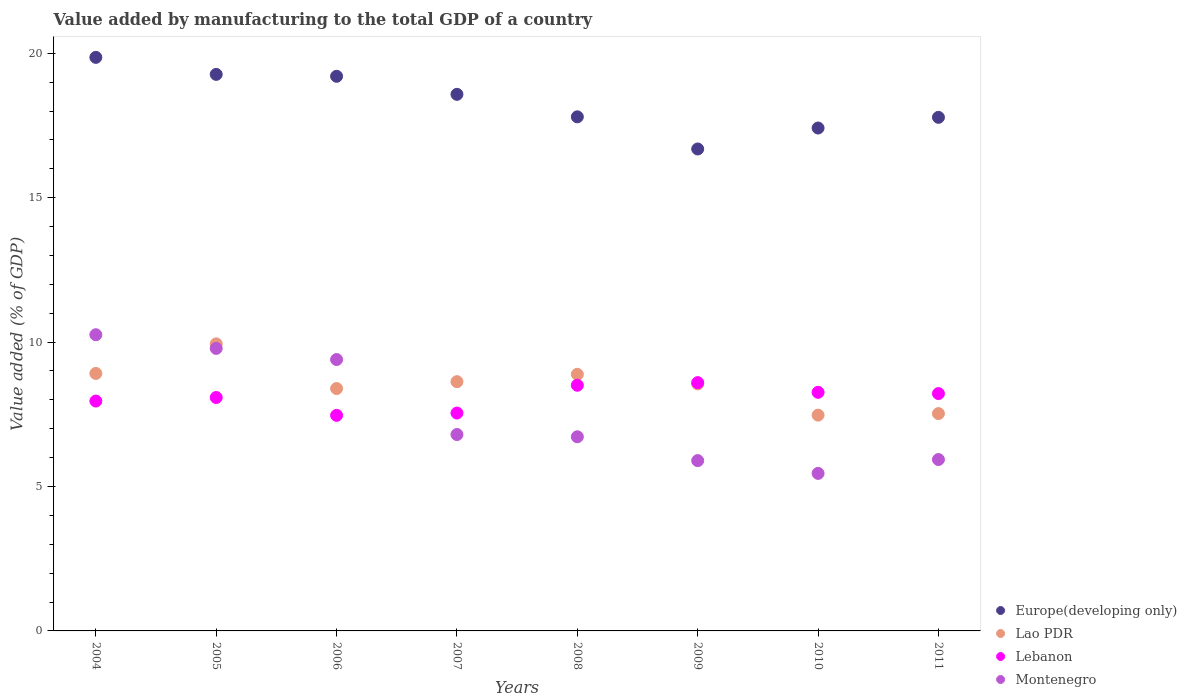What is the value added by manufacturing to the total GDP in Lebanon in 2005?
Give a very brief answer. 8.08. Across all years, what is the maximum value added by manufacturing to the total GDP in Europe(developing only)?
Provide a succinct answer. 19.86. Across all years, what is the minimum value added by manufacturing to the total GDP in Lebanon?
Offer a very short reply. 7.46. In which year was the value added by manufacturing to the total GDP in Montenegro maximum?
Offer a very short reply. 2004. What is the total value added by manufacturing to the total GDP in Lao PDR in the graph?
Your response must be concise. 68.31. What is the difference between the value added by manufacturing to the total GDP in Montenegro in 2005 and that in 2009?
Give a very brief answer. 3.89. What is the difference between the value added by manufacturing to the total GDP in Europe(developing only) in 2005 and the value added by manufacturing to the total GDP in Lao PDR in 2009?
Give a very brief answer. 10.72. What is the average value added by manufacturing to the total GDP in Lebanon per year?
Provide a short and direct response. 8.08. In the year 2008, what is the difference between the value added by manufacturing to the total GDP in Lebanon and value added by manufacturing to the total GDP in Europe(developing only)?
Offer a terse response. -9.29. What is the ratio of the value added by manufacturing to the total GDP in Europe(developing only) in 2007 to that in 2008?
Make the answer very short. 1.04. Is the value added by manufacturing to the total GDP in Europe(developing only) in 2006 less than that in 2010?
Offer a very short reply. No. What is the difference between the highest and the second highest value added by manufacturing to the total GDP in Europe(developing only)?
Offer a terse response. 0.59. What is the difference between the highest and the lowest value added by manufacturing to the total GDP in Europe(developing only)?
Make the answer very short. 3.17. Is it the case that in every year, the sum of the value added by manufacturing to the total GDP in Montenegro and value added by manufacturing to the total GDP in Europe(developing only)  is greater than the sum of value added by manufacturing to the total GDP in Lebanon and value added by manufacturing to the total GDP in Lao PDR?
Your response must be concise. No. Is it the case that in every year, the sum of the value added by manufacturing to the total GDP in Montenegro and value added by manufacturing to the total GDP in Lebanon  is greater than the value added by manufacturing to the total GDP in Europe(developing only)?
Your answer should be compact. No. Is the value added by manufacturing to the total GDP in Lebanon strictly greater than the value added by manufacturing to the total GDP in Europe(developing only) over the years?
Offer a very short reply. No. Are the values on the major ticks of Y-axis written in scientific E-notation?
Keep it short and to the point. No. Does the graph contain any zero values?
Give a very brief answer. No. Where does the legend appear in the graph?
Offer a very short reply. Bottom right. What is the title of the graph?
Make the answer very short. Value added by manufacturing to the total GDP of a country. What is the label or title of the X-axis?
Your answer should be compact. Years. What is the label or title of the Y-axis?
Your answer should be very brief. Value added (% of GDP). What is the Value added (% of GDP) in Europe(developing only) in 2004?
Your response must be concise. 19.86. What is the Value added (% of GDP) of Lao PDR in 2004?
Offer a very short reply. 8.91. What is the Value added (% of GDP) of Lebanon in 2004?
Offer a very short reply. 7.96. What is the Value added (% of GDP) of Montenegro in 2004?
Provide a succinct answer. 10.25. What is the Value added (% of GDP) in Europe(developing only) in 2005?
Your answer should be very brief. 19.27. What is the Value added (% of GDP) of Lao PDR in 2005?
Give a very brief answer. 9.94. What is the Value added (% of GDP) in Lebanon in 2005?
Provide a succinct answer. 8.08. What is the Value added (% of GDP) of Montenegro in 2005?
Give a very brief answer. 9.78. What is the Value added (% of GDP) in Europe(developing only) in 2006?
Offer a terse response. 19.2. What is the Value added (% of GDP) in Lao PDR in 2006?
Offer a very short reply. 8.39. What is the Value added (% of GDP) of Lebanon in 2006?
Provide a short and direct response. 7.46. What is the Value added (% of GDP) in Montenegro in 2006?
Your answer should be compact. 9.4. What is the Value added (% of GDP) in Europe(developing only) in 2007?
Offer a terse response. 18.58. What is the Value added (% of GDP) of Lao PDR in 2007?
Provide a short and direct response. 8.63. What is the Value added (% of GDP) in Lebanon in 2007?
Your answer should be very brief. 7.54. What is the Value added (% of GDP) in Montenegro in 2007?
Give a very brief answer. 6.8. What is the Value added (% of GDP) of Europe(developing only) in 2008?
Provide a short and direct response. 17.8. What is the Value added (% of GDP) of Lao PDR in 2008?
Give a very brief answer. 8.88. What is the Value added (% of GDP) of Lebanon in 2008?
Your answer should be very brief. 8.51. What is the Value added (% of GDP) in Montenegro in 2008?
Provide a succinct answer. 6.72. What is the Value added (% of GDP) in Europe(developing only) in 2009?
Your answer should be very brief. 16.69. What is the Value added (% of GDP) of Lao PDR in 2009?
Keep it short and to the point. 8.55. What is the Value added (% of GDP) of Lebanon in 2009?
Provide a short and direct response. 8.6. What is the Value added (% of GDP) of Montenegro in 2009?
Offer a terse response. 5.9. What is the Value added (% of GDP) of Europe(developing only) in 2010?
Your answer should be compact. 17.41. What is the Value added (% of GDP) of Lao PDR in 2010?
Ensure brevity in your answer.  7.47. What is the Value added (% of GDP) of Lebanon in 2010?
Provide a succinct answer. 8.26. What is the Value added (% of GDP) in Montenegro in 2010?
Give a very brief answer. 5.45. What is the Value added (% of GDP) of Europe(developing only) in 2011?
Provide a succinct answer. 17.78. What is the Value added (% of GDP) of Lao PDR in 2011?
Make the answer very short. 7.52. What is the Value added (% of GDP) of Lebanon in 2011?
Ensure brevity in your answer.  8.22. What is the Value added (% of GDP) in Montenegro in 2011?
Give a very brief answer. 5.93. Across all years, what is the maximum Value added (% of GDP) of Europe(developing only)?
Offer a terse response. 19.86. Across all years, what is the maximum Value added (% of GDP) of Lao PDR?
Your response must be concise. 9.94. Across all years, what is the maximum Value added (% of GDP) of Lebanon?
Provide a short and direct response. 8.6. Across all years, what is the maximum Value added (% of GDP) of Montenegro?
Make the answer very short. 10.25. Across all years, what is the minimum Value added (% of GDP) of Europe(developing only)?
Offer a terse response. 16.69. Across all years, what is the minimum Value added (% of GDP) of Lao PDR?
Offer a very short reply. 7.47. Across all years, what is the minimum Value added (% of GDP) in Lebanon?
Ensure brevity in your answer.  7.46. Across all years, what is the minimum Value added (% of GDP) in Montenegro?
Give a very brief answer. 5.45. What is the total Value added (% of GDP) in Europe(developing only) in the graph?
Offer a very short reply. 146.59. What is the total Value added (% of GDP) of Lao PDR in the graph?
Provide a short and direct response. 68.31. What is the total Value added (% of GDP) of Lebanon in the graph?
Your answer should be compact. 64.63. What is the total Value added (% of GDP) in Montenegro in the graph?
Your answer should be very brief. 60.24. What is the difference between the Value added (% of GDP) in Europe(developing only) in 2004 and that in 2005?
Make the answer very short. 0.59. What is the difference between the Value added (% of GDP) of Lao PDR in 2004 and that in 2005?
Provide a succinct answer. -1.02. What is the difference between the Value added (% of GDP) in Lebanon in 2004 and that in 2005?
Provide a succinct answer. -0.12. What is the difference between the Value added (% of GDP) in Montenegro in 2004 and that in 2005?
Offer a terse response. 0.47. What is the difference between the Value added (% of GDP) in Europe(developing only) in 2004 and that in 2006?
Provide a short and direct response. 0.65. What is the difference between the Value added (% of GDP) of Lao PDR in 2004 and that in 2006?
Provide a succinct answer. 0.52. What is the difference between the Value added (% of GDP) in Lebanon in 2004 and that in 2006?
Give a very brief answer. 0.49. What is the difference between the Value added (% of GDP) in Montenegro in 2004 and that in 2006?
Your answer should be very brief. 0.86. What is the difference between the Value added (% of GDP) of Europe(developing only) in 2004 and that in 2007?
Provide a succinct answer. 1.28. What is the difference between the Value added (% of GDP) in Lao PDR in 2004 and that in 2007?
Your answer should be compact. 0.28. What is the difference between the Value added (% of GDP) in Lebanon in 2004 and that in 2007?
Offer a terse response. 0.42. What is the difference between the Value added (% of GDP) of Montenegro in 2004 and that in 2007?
Your answer should be compact. 3.45. What is the difference between the Value added (% of GDP) of Europe(developing only) in 2004 and that in 2008?
Your answer should be very brief. 2.06. What is the difference between the Value added (% of GDP) in Lao PDR in 2004 and that in 2008?
Your answer should be very brief. 0.03. What is the difference between the Value added (% of GDP) in Lebanon in 2004 and that in 2008?
Your answer should be compact. -0.55. What is the difference between the Value added (% of GDP) of Montenegro in 2004 and that in 2008?
Your answer should be compact. 3.53. What is the difference between the Value added (% of GDP) of Europe(developing only) in 2004 and that in 2009?
Keep it short and to the point. 3.17. What is the difference between the Value added (% of GDP) in Lao PDR in 2004 and that in 2009?
Give a very brief answer. 0.36. What is the difference between the Value added (% of GDP) in Lebanon in 2004 and that in 2009?
Your answer should be very brief. -0.64. What is the difference between the Value added (% of GDP) of Montenegro in 2004 and that in 2009?
Your response must be concise. 4.36. What is the difference between the Value added (% of GDP) in Europe(developing only) in 2004 and that in 2010?
Your answer should be compact. 2.45. What is the difference between the Value added (% of GDP) of Lao PDR in 2004 and that in 2010?
Offer a terse response. 1.44. What is the difference between the Value added (% of GDP) of Lebanon in 2004 and that in 2010?
Ensure brevity in your answer.  -0.3. What is the difference between the Value added (% of GDP) of Montenegro in 2004 and that in 2010?
Make the answer very short. 4.8. What is the difference between the Value added (% of GDP) of Europe(developing only) in 2004 and that in 2011?
Make the answer very short. 2.08. What is the difference between the Value added (% of GDP) in Lao PDR in 2004 and that in 2011?
Your response must be concise. 1.39. What is the difference between the Value added (% of GDP) of Lebanon in 2004 and that in 2011?
Provide a succinct answer. -0.26. What is the difference between the Value added (% of GDP) of Montenegro in 2004 and that in 2011?
Your response must be concise. 4.32. What is the difference between the Value added (% of GDP) in Europe(developing only) in 2005 and that in 2006?
Provide a succinct answer. 0.07. What is the difference between the Value added (% of GDP) in Lao PDR in 2005 and that in 2006?
Give a very brief answer. 1.55. What is the difference between the Value added (% of GDP) of Lebanon in 2005 and that in 2006?
Provide a short and direct response. 0.62. What is the difference between the Value added (% of GDP) of Montenegro in 2005 and that in 2006?
Offer a very short reply. 0.39. What is the difference between the Value added (% of GDP) of Europe(developing only) in 2005 and that in 2007?
Keep it short and to the point. 0.69. What is the difference between the Value added (% of GDP) of Lao PDR in 2005 and that in 2007?
Provide a succinct answer. 1.31. What is the difference between the Value added (% of GDP) in Lebanon in 2005 and that in 2007?
Your answer should be compact. 0.54. What is the difference between the Value added (% of GDP) in Montenegro in 2005 and that in 2007?
Your answer should be compact. 2.98. What is the difference between the Value added (% of GDP) in Europe(developing only) in 2005 and that in 2008?
Offer a very short reply. 1.47. What is the difference between the Value added (% of GDP) in Lao PDR in 2005 and that in 2008?
Keep it short and to the point. 1.05. What is the difference between the Value added (% of GDP) of Lebanon in 2005 and that in 2008?
Your response must be concise. -0.42. What is the difference between the Value added (% of GDP) of Montenegro in 2005 and that in 2008?
Provide a short and direct response. 3.06. What is the difference between the Value added (% of GDP) in Europe(developing only) in 2005 and that in 2009?
Your answer should be very brief. 2.58. What is the difference between the Value added (% of GDP) of Lao PDR in 2005 and that in 2009?
Offer a terse response. 1.39. What is the difference between the Value added (% of GDP) of Lebanon in 2005 and that in 2009?
Provide a short and direct response. -0.52. What is the difference between the Value added (% of GDP) of Montenegro in 2005 and that in 2009?
Provide a succinct answer. 3.89. What is the difference between the Value added (% of GDP) of Europe(developing only) in 2005 and that in 2010?
Make the answer very short. 1.86. What is the difference between the Value added (% of GDP) in Lao PDR in 2005 and that in 2010?
Your answer should be compact. 2.47. What is the difference between the Value added (% of GDP) of Lebanon in 2005 and that in 2010?
Provide a succinct answer. -0.18. What is the difference between the Value added (% of GDP) of Montenegro in 2005 and that in 2010?
Your answer should be very brief. 4.33. What is the difference between the Value added (% of GDP) in Europe(developing only) in 2005 and that in 2011?
Provide a succinct answer. 1.49. What is the difference between the Value added (% of GDP) of Lao PDR in 2005 and that in 2011?
Provide a succinct answer. 2.41. What is the difference between the Value added (% of GDP) in Lebanon in 2005 and that in 2011?
Make the answer very short. -0.14. What is the difference between the Value added (% of GDP) in Montenegro in 2005 and that in 2011?
Keep it short and to the point. 3.85. What is the difference between the Value added (% of GDP) of Europe(developing only) in 2006 and that in 2007?
Your answer should be very brief. 0.62. What is the difference between the Value added (% of GDP) of Lao PDR in 2006 and that in 2007?
Keep it short and to the point. -0.24. What is the difference between the Value added (% of GDP) in Lebanon in 2006 and that in 2007?
Your answer should be very brief. -0.08. What is the difference between the Value added (% of GDP) in Montenegro in 2006 and that in 2007?
Keep it short and to the point. 2.6. What is the difference between the Value added (% of GDP) in Europe(developing only) in 2006 and that in 2008?
Make the answer very short. 1.4. What is the difference between the Value added (% of GDP) of Lao PDR in 2006 and that in 2008?
Provide a short and direct response. -0.49. What is the difference between the Value added (% of GDP) in Lebanon in 2006 and that in 2008?
Provide a succinct answer. -1.04. What is the difference between the Value added (% of GDP) in Montenegro in 2006 and that in 2008?
Make the answer very short. 2.67. What is the difference between the Value added (% of GDP) of Europe(developing only) in 2006 and that in 2009?
Make the answer very short. 2.52. What is the difference between the Value added (% of GDP) of Lao PDR in 2006 and that in 2009?
Give a very brief answer. -0.16. What is the difference between the Value added (% of GDP) in Lebanon in 2006 and that in 2009?
Provide a short and direct response. -1.13. What is the difference between the Value added (% of GDP) in Montenegro in 2006 and that in 2009?
Make the answer very short. 3.5. What is the difference between the Value added (% of GDP) of Europe(developing only) in 2006 and that in 2010?
Ensure brevity in your answer.  1.79. What is the difference between the Value added (% of GDP) of Lao PDR in 2006 and that in 2010?
Offer a very short reply. 0.92. What is the difference between the Value added (% of GDP) of Lebanon in 2006 and that in 2010?
Ensure brevity in your answer.  -0.8. What is the difference between the Value added (% of GDP) in Montenegro in 2006 and that in 2010?
Keep it short and to the point. 3.94. What is the difference between the Value added (% of GDP) in Europe(developing only) in 2006 and that in 2011?
Make the answer very short. 1.42. What is the difference between the Value added (% of GDP) of Lao PDR in 2006 and that in 2011?
Offer a terse response. 0.87. What is the difference between the Value added (% of GDP) in Lebanon in 2006 and that in 2011?
Give a very brief answer. -0.75. What is the difference between the Value added (% of GDP) of Montenegro in 2006 and that in 2011?
Offer a terse response. 3.46. What is the difference between the Value added (% of GDP) in Europe(developing only) in 2007 and that in 2008?
Keep it short and to the point. 0.78. What is the difference between the Value added (% of GDP) in Lao PDR in 2007 and that in 2008?
Make the answer very short. -0.25. What is the difference between the Value added (% of GDP) of Lebanon in 2007 and that in 2008?
Ensure brevity in your answer.  -0.96. What is the difference between the Value added (% of GDP) of Montenegro in 2007 and that in 2008?
Provide a short and direct response. 0.08. What is the difference between the Value added (% of GDP) in Europe(developing only) in 2007 and that in 2009?
Give a very brief answer. 1.89. What is the difference between the Value added (% of GDP) of Lao PDR in 2007 and that in 2009?
Give a very brief answer. 0.08. What is the difference between the Value added (% of GDP) of Lebanon in 2007 and that in 2009?
Offer a terse response. -1.05. What is the difference between the Value added (% of GDP) in Montenegro in 2007 and that in 2009?
Your response must be concise. 0.9. What is the difference between the Value added (% of GDP) in Europe(developing only) in 2007 and that in 2010?
Your answer should be very brief. 1.17. What is the difference between the Value added (% of GDP) in Lao PDR in 2007 and that in 2010?
Keep it short and to the point. 1.16. What is the difference between the Value added (% of GDP) of Lebanon in 2007 and that in 2010?
Provide a short and direct response. -0.72. What is the difference between the Value added (% of GDP) of Montenegro in 2007 and that in 2010?
Provide a short and direct response. 1.35. What is the difference between the Value added (% of GDP) of Europe(developing only) in 2007 and that in 2011?
Provide a short and direct response. 0.8. What is the difference between the Value added (% of GDP) in Lao PDR in 2007 and that in 2011?
Offer a terse response. 1.11. What is the difference between the Value added (% of GDP) of Lebanon in 2007 and that in 2011?
Give a very brief answer. -0.67. What is the difference between the Value added (% of GDP) of Montenegro in 2007 and that in 2011?
Keep it short and to the point. 0.87. What is the difference between the Value added (% of GDP) in Europe(developing only) in 2008 and that in 2009?
Your response must be concise. 1.11. What is the difference between the Value added (% of GDP) in Lao PDR in 2008 and that in 2009?
Ensure brevity in your answer.  0.33. What is the difference between the Value added (% of GDP) of Lebanon in 2008 and that in 2009?
Keep it short and to the point. -0.09. What is the difference between the Value added (% of GDP) in Montenegro in 2008 and that in 2009?
Provide a succinct answer. 0.83. What is the difference between the Value added (% of GDP) in Europe(developing only) in 2008 and that in 2010?
Your answer should be very brief. 0.39. What is the difference between the Value added (% of GDP) in Lao PDR in 2008 and that in 2010?
Give a very brief answer. 1.41. What is the difference between the Value added (% of GDP) of Lebanon in 2008 and that in 2010?
Offer a very short reply. 0.25. What is the difference between the Value added (% of GDP) of Montenegro in 2008 and that in 2010?
Ensure brevity in your answer.  1.27. What is the difference between the Value added (% of GDP) of Europe(developing only) in 2008 and that in 2011?
Provide a succinct answer. 0.02. What is the difference between the Value added (% of GDP) in Lao PDR in 2008 and that in 2011?
Your answer should be very brief. 1.36. What is the difference between the Value added (% of GDP) in Lebanon in 2008 and that in 2011?
Provide a short and direct response. 0.29. What is the difference between the Value added (% of GDP) in Montenegro in 2008 and that in 2011?
Your response must be concise. 0.79. What is the difference between the Value added (% of GDP) of Europe(developing only) in 2009 and that in 2010?
Provide a succinct answer. -0.73. What is the difference between the Value added (% of GDP) in Lao PDR in 2009 and that in 2010?
Your answer should be compact. 1.08. What is the difference between the Value added (% of GDP) in Lebanon in 2009 and that in 2010?
Your response must be concise. 0.34. What is the difference between the Value added (% of GDP) in Montenegro in 2009 and that in 2010?
Provide a short and direct response. 0.44. What is the difference between the Value added (% of GDP) of Europe(developing only) in 2009 and that in 2011?
Your answer should be compact. -1.1. What is the difference between the Value added (% of GDP) of Lao PDR in 2009 and that in 2011?
Ensure brevity in your answer.  1.03. What is the difference between the Value added (% of GDP) of Lebanon in 2009 and that in 2011?
Give a very brief answer. 0.38. What is the difference between the Value added (% of GDP) in Montenegro in 2009 and that in 2011?
Keep it short and to the point. -0.04. What is the difference between the Value added (% of GDP) of Europe(developing only) in 2010 and that in 2011?
Your response must be concise. -0.37. What is the difference between the Value added (% of GDP) in Lao PDR in 2010 and that in 2011?
Your response must be concise. -0.05. What is the difference between the Value added (% of GDP) of Lebanon in 2010 and that in 2011?
Your answer should be compact. 0.04. What is the difference between the Value added (% of GDP) in Montenegro in 2010 and that in 2011?
Make the answer very short. -0.48. What is the difference between the Value added (% of GDP) of Europe(developing only) in 2004 and the Value added (% of GDP) of Lao PDR in 2005?
Ensure brevity in your answer.  9.92. What is the difference between the Value added (% of GDP) in Europe(developing only) in 2004 and the Value added (% of GDP) in Lebanon in 2005?
Your answer should be compact. 11.78. What is the difference between the Value added (% of GDP) of Europe(developing only) in 2004 and the Value added (% of GDP) of Montenegro in 2005?
Provide a short and direct response. 10.08. What is the difference between the Value added (% of GDP) of Lao PDR in 2004 and the Value added (% of GDP) of Lebanon in 2005?
Your answer should be very brief. 0.83. What is the difference between the Value added (% of GDP) in Lao PDR in 2004 and the Value added (% of GDP) in Montenegro in 2005?
Your answer should be very brief. -0.87. What is the difference between the Value added (% of GDP) of Lebanon in 2004 and the Value added (% of GDP) of Montenegro in 2005?
Offer a very short reply. -1.82. What is the difference between the Value added (% of GDP) in Europe(developing only) in 2004 and the Value added (% of GDP) in Lao PDR in 2006?
Your response must be concise. 11.47. What is the difference between the Value added (% of GDP) of Europe(developing only) in 2004 and the Value added (% of GDP) of Lebanon in 2006?
Offer a very short reply. 12.39. What is the difference between the Value added (% of GDP) in Europe(developing only) in 2004 and the Value added (% of GDP) in Montenegro in 2006?
Keep it short and to the point. 10.46. What is the difference between the Value added (% of GDP) of Lao PDR in 2004 and the Value added (% of GDP) of Lebanon in 2006?
Provide a short and direct response. 1.45. What is the difference between the Value added (% of GDP) in Lao PDR in 2004 and the Value added (% of GDP) in Montenegro in 2006?
Provide a succinct answer. -0.48. What is the difference between the Value added (% of GDP) in Lebanon in 2004 and the Value added (% of GDP) in Montenegro in 2006?
Provide a succinct answer. -1.44. What is the difference between the Value added (% of GDP) of Europe(developing only) in 2004 and the Value added (% of GDP) of Lao PDR in 2007?
Your answer should be compact. 11.23. What is the difference between the Value added (% of GDP) of Europe(developing only) in 2004 and the Value added (% of GDP) of Lebanon in 2007?
Make the answer very short. 12.31. What is the difference between the Value added (% of GDP) in Europe(developing only) in 2004 and the Value added (% of GDP) in Montenegro in 2007?
Provide a short and direct response. 13.06. What is the difference between the Value added (% of GDP) of Lao PDR in 2004 and the Value added (% of GDP) of Lebanon in 2007?
Your answer should be very brief. 1.37. What is the difference between the Value added (% of GDP) in Lao PDR in 2004 and the Value added (% of GDP) in Montenegro in 2007?
Provide a short and direct response. 2.11. What is the difference between the Value added (% of GDP) of Lebanon in 2004 and the Value added (% of GDP) of Montenegro in 2007?
Provide a short and direct response. 1.16. What is the difference between the Value added (% of GDP) of Europe(developing only) in 2004 and the Value added (% of GDP) of Lao PDR in 2008?
Your answer should be very brief. 10.97. What is the difference between the Value added (% of GDP) of Europe(developing only) in 2004 and the Value added (% of GDP) of Lebanon in 2008?
Provide a short and direct response. 11.35. What is the difference between the Value added (% of GDP) in Europe(developing only) in 2004 and the Value added (% of GDP) in Montenegro in 2008?
Ensure brevity in your answer.  13.14. What is the difference between the Value added (% of GDP) of Lao PDR in 2004 and the Value added (% of GDP) of Lebanon in 2008?
Make the answer very short. 0.41. What is the difference between the Value added (% of GDP) in Lao PDR in 2004 and the Value added (% of GDP) in Montenegro in 2008?
Your answer should be very brief. 2.19. What is the difference between the Value added (% of GDP) in Lebanon in 2004 and the Value added (% of GDP) in Montenegro in 2008?
Ensure brevity in your answer.  1.24. What is the difference between the Value added (% of GDP) in Europe(developing only) in 2004 and the Value added (% of GDP) in Lao PDR in 2009?
Make the answer very short. 11.31. What is the difference between the Value added (% of GDP) in Europe(developing only) in 2004 and the Value added (% of GDP) in Lebanon in 2009?
Ensure brevity in your answer.  11.26. What is the difference between the Value added (% of GDP) of Europe(developing only) in 2004 and the Value added (% of GDP) of Montenegro in 2009?
Keep it short and to the point. 13.96. What is the difference between the Value added (% of GDP) in Lao PDR in 2004 and the Value added (% of GDP) in Lebanon in 2009?
Your answer should be compact. 0.32. What is the difference between the Value added (% of GDP) in Lao PDR in 2004 and the Value added (% of GDP) in Montenegro in 2009?
Keep it short and to the point. 3.02. What is the difference between the Value added (% of GDP) in Lebanon in 2004 and the Value added (% of GDP) in Montenegro in 2009?
Your answer should be very brief. 2.06. What is the difference between the Value added (% of GDP) of Europe(developing only) in 2004 and the Value added (% of GDP) of Lao PDR in 2010?
Give a very brief answer. 12.39. What is the difference between the Value added (% of GDP) in Europe(developing only) in 2004 and the Value added (% of GDP) in Lebanon in 2010?
Provide a short and direct response. 11.6. What is the difference between the Value added (% of GDP) in Europe(developing only) in 2004 and the Value added (% of GDP) in Montenegro in 2010?
Keep it short and to the point. 14.4. What is the difference between the Value added (% of GDP) of Lao PDR in 2004 and the Value added (% of GDP) of Lebanon in 2010?
Give a very brief answer. 0.65. What is the difference between the Value added (% of GDP) in Lao PDR in 2004 and the Value added (% of GDP) in Montenegro in 2010?
Offer a very short reply. 3.46. What is the difference between the Value added (% of GDP) in Lebanon in 2004 and the Value added (% of GDP) in Montenegro in 2010?
Make the answer very short. 2.5. What is the difference between the Value added (% of GDP) in Europe(developing only) in 2004 and the Value added (% of GDP) in Lao PDR in 2011?
Your response must be concise. 12.33. What is the difference between the Value added (% of GDP) of Europe(developing only) in 2004 and the Value added (% of GDP) of Lebanon in 2011?
Offer a very short reply. 11.64. What is the difference between the Value added (% of GDP) of Europe(developing only) in 2004 and the Value added (% of GDP) of Montenegro in 2011?
Ensure brevity in your answer.  13.92. What is the difference between the Value added (% of GDP) in Lao PDR in 2004 and the Value added (% of GDP) in Lebanon in 2011?
Your response must be concise. 0.7. What is the difference between the Value added (% of GDP) in Lao PDR in 2004 and the Value added (% of GDP) in Montenegro in 2011?
Provide a short and direct response. 2.98. What is the difference between the Value added (% of GDP) in Lebanon in 2004 and the Value added (% of GDP) in Montenegro in 2011?
Provide a short and direct response. 2.02. What is the difference between the Value added (% of GDP) of Europe(developing only) in 2005 and the Value added (% of GDP) of Lao PDR in 2006?
Ensure brevity in your answer.  10.88. What is the difference between the Value added (% of GDP) in Europe(developing only) in 2005 and the Value added (% of GDP) in Lebanon in 2006?
Provide a short and direct response. 11.81. What is the difference between the Value added (% of GDP) in Europe(developing only) in 2005 and the Value added (% of GDP) in Montenegro in 2006?
Keep it short and to the point. 9.87. What is the difference between the Value added (% of GDP) of Lao PDR in 2005 and the Value added (% of GDP) of Lebanon in 2006?
Provide a succinct answer. 2.48. What is the difference between the Value added (% of GDP) of Lao PDR in 2005 and the Value added (% of GDP) of Montenegro in 2006?
Your answer should be very brief. 0.54. What is the difference between the Value added (% of GDP) in Lebanon in 2005 and the Value added (% of GDP) in Montenegro in 2006?
Give a very brief answer. -1.31. What is the difference between the Value added (% of GDP) in Europe(developing only) in 2005 and the Value added (% of GDP) in Lao PDR in 2007?
Your response must be concise. 10.64. What is the difference between the Value added (% of GDP) in Europe(developing only) in 2005 and the Value added (% of GDP) in Lebanon in 2007?
Provide a succinct answer. 11.73. What is the difference between the Value added (% of GDP) of Europe(developing only) in 2005 and the Value added (% of GDP) of Montenegro in 2007?
Your response must be concise. 12.47. What is the difference between the Value added (% of GDP) of Lao PDR in 2005 and the Value added (% of GDP) of Lebanon in 2007?
Your response must be concise. 2.4. What is the difference between the Value added (% of GDP) of Lao PDR in 2005 and the Value added (% of GDP) of Montenegro in 2007?
Keep it short and to the point. 3.14. What is the difference between the Value added (% of GDP) in Lebanon in 2005 and the Value added (% of GDP) in Montenegro in 2007?
Your answer should be compact. 1.28. What is the difference between the Value added (% of GDP) in Europe(developing only) in 2005 and the Value added (% of GDP) in Lao PDR in 2008?
Provide a succinct answer. 10.38. What is the difference between the Value added (% of GDP) of Europe(developing only) in 2005 and the Value added (% of GDP) of Lebanon in 2008?
Provide a short and direct response. 10.76. What is the difference between the Value added (% of GDP) of Europe(developing only) in 2005 and the Value added (% of GDP) of Montenegro in 2008?
Your answer should be very brief. 12.55. What is the difference between the Value added (% of GDP) in Lao PDR in 2005 and the Value added (% of GDP) in Lebanon in 2008?
Provide a succinct answer. 1.43. What is the difference between the Value added (% of GDP) in Lao PDR in 2005 and the Value added (% of GDP) in Montenegro in 2008?
Offer a terse response. 3.22. What is the difference between the Value added (% of GDP) of Lebanon in 2005 and the Value added (% of GDP) of Montenegro in 2008?
Ensure brevity in your answer.  1.36. What is the difference between the Value added (% of GDP) of Europe(developing only) in 2005 and the Value added (% of GDP) of Lao PDR in 2009?
Your answer should be compact. 10.72. What is the difference between the Value added (% of GDP) of Europe(developing only) in 2005 and the Value added (% of GDP) of Lebanon in 2009?
Provide a succinct answer. 10.67. What is the difference between the Value added (% of GDP) of Europe(developing only) in 2005 and the Value added (% of GDP) of Montenegro in 2009?
Ensure brevity in your answer.  13.37. What is the difference between the Value added (% of GDP) of Lao PDR in 2005 and the Value added (% of GDP) of Lebanon in 2009?
Offer a terse response. 1.34. What is the difference between the Value added (% of GDP) of Lao PDR in 2005 and the Value added (% of GDP) of Montenegro in 2009?
Your answer should be compact. 4.04. What is the difference between the Value added (% of GDP) of Lebanon in 2005 and the Value added (% of GDP) of Montenegro in 2009?
Ensure brevity in your answer.  2.19. What is the difference between the Value added (% of GDP) of Europe(developing only) in 2005 and the Value added (% of GDP) of Lao PDR in 2010?
Provide a short and direct response. 11.8. What is the difference between the Value added (% of GDP) of Europe(developing only) in 2005 and the Value added (% of GDP) of Lebanon in 2010?
Provide a short and direct response. 11.01. What is the difference between the Value added (% of GDP) in Europe(developing only) in 2005 and the Value added (% of GDP) in Montenegro in 2010?
Provide a succinct answer. 13.81. What is the difference between the Value added (% of GDP) in Lao PDR in 2005 and the Value added (% of GDP) in Lebanon in 2010?
Keep it short and to the point. 1.68. What is the difference between the Value added (% of GDP) in Lao PDR in 2005 and the Value added (% of GDP) in Montenegro in 2010?
Your response must be concise. 4.48. What is the difference between the Value added (% of GDP) of Lebanon in 2005 and the Value added (% of GDP) of Montenegro in 2010?
Provide a short and direct response. 2.63. What is the difference between the Value added (% of GDP) of Europe(developing only) in 2005 and the Value added (% of GDP) of Lao PDR in 2011?
Your response must be concise. 11.74. What is the difference between the Value added (% of GDP) in Europe(developing only) in 2005 and the Value added (% of GDP) in Lebanon in 2011?
Provide a short and direct response. 11.05. What is the difference between the Value added (% of GDP) in Europe(developing only) in 2005 and the Value added (% of GDP) in Montenegro in 2011?
Your answer should be compact. 13.34. What is the difference between the Value added (% of GDP) in Lao PDR in 2005 and the Value added (% of GDP) in Lebanon in 2011?
Your answer should be compact. 1.72. What is the difference between the Value added (% of GDP) of Lao PDR in 2005 and the Value added (% of GDP) of Montenegro in 2011?
Ensure brevity in your answer.  4.01. What is the difference between the Value added (% of GDP) in Lebanon in 2005 and the Value added (% of GDP) in Montenegro in 2011?
Keep it short and to the point. 2.15. What is the difference between the Value added (% of GDP) of Europe(developing only) in 2006 and the Value added (% of GDP) of Lao PDR in 2007?
Your answer should be compact. 10.57. What is the difference between the Value added (% of GDP) of Europe(developing only) in 2006 and the Value added (% of GDP) of Lebanon in 2007?
Your answer should be very brief. 11.66. What is the difference between the Value added (% of GDP) of Europe(developing only) in 2006 and the Value added (% of GDP) of Montenegro in 2007?
Provide a short and direct response. 12.4. What is the difference between the Value added (% of GDP) of Lao PDR in 2006 and the Value added (% of GDP) of Lebanon in 2007?
Ensure brevity in your answer.  0.85. What is the difference between the Value added (% of GDP) in Lao PDR in 2006 and the Value added (% of GDP) in Montenegro in 2007?
Make the answer very short. 1.59. What is the difference between the Value added (% of GDP) in Lebanon in 2006 and the Value added (% of GDP) in Montenegro in 2007?
Provide a succinct answer. 0.66. What is the difference between the Value added (% of GDP) of Europe(developing only) in 2006 and the Value added (% of GDP) of Lao PDR in 2008?
Make the answer very short. 10.32. What is the difference between the Value added (% of GDP) in Europe(developing only) in 2006 and the Value added (% of GDP) in Lebanon in 2008?
Offer a terse response. 10.7. What is the difference between the Value added (% of GDP) of Europe(developing only) in 2006 and the Value added (% of GDP) of Montenegro in 2008?
Provide a succinct answer. 12.48. What is the difference between the Value added (% of GDP) in Lao PDR in 2006 and the Value added (% of GDP) in Lebanon in 2008?
Offer a terse response. -0.11. What is the difference between the Value added (% of GDP) of Lao PDR in 2006 and the Value added (% of GDP) of Montenegro in 2008?
Your response must be concise. 1.67. What is the difference between the Value added (% of GDP) of Lebanon in 2006 and the Value added (% of GDP) of Montenegro in 2008?
Offer a very short reply. 0.74. What is the difference between the Value added (% of GDP) of Europe(developing only) in 2006 and the Value added (% of GDP) of Lao PDR in 2009?
Offer a terse response. 10.65. What is the difference between the Value added (% of GDP) of Europe(developing only) in 2006 and the Value added (% of GDP) of Lebanon in 2009?
Give a very brief answer. 10.61. What is the difference between the Value added (% of GDP) of Europe(developing only) in 2006 and the Value added (% of GDP) of Montenegro in 2009?
Ensure brevity in your answer.  13.31. What is the difference between the Value added (% of GDP) of Lao PDR in 2006 and the Value added (% of GDP) of Lebanon in 2009?
Keep it short and to the point. -0.21. What is the difference between the Value added (% of GDP) of Lao PDR in 2006 and the Value added (% of GDP) of Montenegro in 2009?
Keep it short and to the point. 2.5. What is the difference between the Value added (% of GDP) of Lebanon in 2006 and the Value added (% of GDP) of Montenegro in 2009?
Your answer should be compact. 1.57. What is the difference between the Value added (% of GDP) in Europe(developing only) in 2006 and the Value added (% of GDP) in Lao PDR in 2010?
Your response must be concise. 11.73. What is the difference between the Value added (% of GDP) in Europe(developing only) in 2006 and the Value added (% of GDP) in Lebanon in 2010?
Offer a terse response. 10.94. What is the difference between the Value added (% of GDP) in Europe(developing only) in 2006 and the Value added (% of GDP) in Montenegro in 2010?
Your answer should be very brief. 13.75. What is the difference between the Value added (% of GDP) in Lao PDR in 2006 and the Value added (% of GDP) in Lebanon in 2010?
Offer a terse response. 0.13. What is the difference between the Value added (% of GDP) in Lao PDR in 2006 and the Value added (% of GDP) in Montenegro in 2010?
Keep it short and to the point. 2.94. What is the difference between the Value added (% of GDP) in Lebanon in 2006 and the Value added (% of GDP) in Montenegro in 2010?
Offer a terse response. 2.01. What is the difference between the Value added (% of GDP) of Europe(developing only) in 2006 and the Value added (% of GDP) of Lao PDR in 2011?
Give a very brief answer. 11.68. What is the difference between the Value added (% of GDP) of Europe(developing only) in 2006 and the Value added (% of GDP) of Lebanon in 2011?
Provide a succinct answer. 10.99. What is the difference between the Value added (% of GDP) of Europe(developing only) in 2006 and the Value added (% of GDP) of Montenegro in 2011?
Your answer should be very brief. 13.27. What is the difference between the Value added (% of GDP) of Lao PDR in 2006 and the Value added (% of GDP) of Lebanon in 2011?
Make the answer very short. 0.17. What is the difference between the Value added (% of GDP) of Lao PDR in 2006 and the Value added (% of GDP) of Montenegro in 2011?
Provide a short and direct response. 2.46. What is the difference between the Value added (% of GDP) of Lebanon in 2006 and the Value added (% of GDP) of Montenegro in 2011?
Provide a short and direct response. 1.53. What is the difference between the Value added (% of GDP) of Europe(developing only) in 2007 and the Value added (% of GDP) of Lao PDR in 2008?
Keep it short and to the point. 9.69. What is the difference between the Value added (% of GDP) in Europe(developing only) in 2007 and the Value added (% of GDP) in Lebanon in 2008?
Provide a short and direct response. 10.07. What is the difference between the Value added (% of GDP) in Europe(developing only) in 2007 and the Value added (% of GDP) in Montenegro in 2008?
Keep it short and to the point. 11.86. What is the difference between the Value added (% of GDP) in Lao PDR in 2007 and the Value added (% of GDP) in Lebanon in 2008?
Offer a terse response. 0.12. What is the difference between the Value added (% of GDP) of Lao PDR in 2007 and the Value added (% of GDP) of Montenegro in 2008?
Keep it short and to the point. 1.91. What is the difference between the Value added (% of GDP) in Lebanon in 2007 and the Value added (% of GDP) in Montenegro in 2008?
Your answer should be very brief. 0.82. What is the difference between the Value added (% of GDP) in Europe(developing only) in 2007 and the Value added (% of GDP) in Lao PDR in 2009?
Provide a short and direct response. 10.03. What is the difference between the Value added (% of GDP) of Europe(developing only) in 2007 and the Value added (% of GDP) of Lebanon in 2009?
Provide a succinct answer. 9.98. What is the difference between the Value added (% of GDP) in Europe(developing only) in 2007 and the Value added (% of GDP) in Montenegro in 2009?
Offer a very short reply. 12.68. What is the difference between the Value added (% of GDP) in Lao PDR in 2007 and the Value added (% of GDP) in Lebanon in 2009?
Your answer should be very brief. 0.03. What is the difference between the Value added (% of GDP) of Lao PDR in 2007 and the Value added (% of GDP) of Montenegro in 2009?
Your answer should be very brief. 2.73. What is the difference between the Value added (% of GDP) in Lebanon in 2007 and the Value added (% of GDP) in Montenegro in 2009?
Ensure brevity in your answer.  1.65. What is the difference between the Value added (% of GDP) in Europe(developing only) in 2007 and the Value added (% of GDP) in Lao PDR in 2010?
Offer a terse response. 11.11. What is the difference between the Value added (% of GDP) in Europe(developing only) in 2007 and the Value added (% of GDP) in Lebanon in 2010?
Provide a short and direct response. 10.32. What is the difference between the Value added (% of GDP) of Europe(developing only) in 2007 and the Value added (% of GDP) of Montenegro in 2010?
Offer a terse response. 13.12. What is the difference between the Value added (% of GDP) in Lao PDR in 2007 and the Value added (% of GDP) in Lebanon in 2010?
Your response must be concise. 0.37. What is the difference between the Value added (% of GDP) of Lao PDR in 2007 and the Value added (% of GDP) of Montenegro in 2010?
Give a very brief answer. 3.18. What is the difference between the Value added (% of GDP) in Lebanon in 2007 and the Value added (% of GDP) in Montenegro in 2010?
Your answer should be very brief. 2.09. What is the difference between the Value added (% of GDP) of Europe(developing only) in 2007 and the Value added (% of GDP) of Lao PDR in 2011?
Your answer should be compact. 11.05. What is the difference between the Value added (% of GDP) in Europe(developing only) in 2007 and the Value added (% of GDP) in Lebanon in 2011?
Give a very brief answer. 10.36. What is the difference between the Value added (% of GDP) of Europe(developing only) in 2007 and the Value added (% of GDP) of Montenegro in 2011?
Provide a succinct answer. 12.64. What is the difference between the Value added (% of GDP) in Lao PDR in 2007 and the Value added (% of GDP) in Lebanon in 2011?
Your response must be concise. 0.41. What is the difference between the Value added (% of GDP) in Lao PDR in 2007 and the Value added (% of GDP) in Montenegro in 2011?
Offer a terse response. 2.7. What is the difference between the Value added (% of GDP) of Lebanon in 2007 and the Value added (% of GDP) of Montenegro in 2011?
Your response must be concise. 1.61. What is the difference between the Value added (% of GDP) in Europe(developing only) in 2008 and the Value added (% of GDP) in Lao PDR in 2009?
Provide a succinct answer. 9.25. What is the difference between the Value added (% of GDP) of Europe(developing only) in 2008 and the Value added (% of GDP) of Lebanon in 2009?
Keep it short and to the point. 9.2. What is the difference between the Value added (% of GDP) of Europe(developing only) in 2008 and the Value added (% of GDP) of Montenegro in 2009?
Ensure brevity in your answer.  11.9. What is the difference between the Value added (% of GDP) in Lao PDR in 2008 and the Value added (% of GDP) in Lebanon in 2009?
Your answer should be very brief. 0.29. What is the difference between the Value added (% of GDP) of Lao PDR in 2008 and the Value added (% of GDP) of Montenegro in 2009?
Provide a short and direct response. 2.99. What is the difference between the Value added (% of GDP) of Lebanon in 2008 and the Value added (% of GDP) of Montenegro in 2009?
Offer a terse response. 2.61. What is the difference between the Value added (% of GDP) of Europe(developing only) in 2008 and the Value added (% of GDP) of Lao PDR in 2010?
Your answer should be compact. 10.33. What is the difference between the Value added (% of GDP) of Europe(developing only) in 2008 and the Value added (% of GDP) of Lebanon in 2010?
Your response must be concise. 9.54. What is the difference between the Value added (% of GDP) of Europe(developing only) in 2008 and the Value added (% of GDP) of Montenegro in 2010?
Your answer should be compact. 12.34. What is the difference between the Value added (% of GDP) in Lao PDR in 2008 and the Value added (% of GDP) in Lebanon in 2010?
Provide a short and direct response. 0.62. What is the difference between the Value added (% of GDP) in Lao PDR in 2008 and the Value added (% of GDP) in Montenegro in 2010?
Offer a terse response. 3.43. What is the difference between the Value added (% of GDP) of Lebanon in 2008 and the Value added (% of GDP) of Montenegro in 2010?
Your response must be concise. 3.05. What is the difference between the Value added (% of GDP) in Europe(developing only) in 2008 and the Value added (% of GDP) in Lao PDR in 2011?
Your response must be concise. 10.27. What is the difference between the Value added (% of GDP) in Europe(developing only) in 2008 and the Value added (% of GDP) in Lebanon in 2011?
Provide a succinct answer. 9.58. What is the difference between the Value added (% of GDP) of Europe(developing only) in 2008 and the Value added (% of GDP) of Montenegro in 2011?
Offer a terse response. 11.87. What is the difference between the Value added (% of GDP) in Lao PDR in 2008 and the Value added (% of GDP) in Lebanon in 2011?
Keep it short and to the point. 0.67. What is the difference between the Value added (% of GDP) of Lao PDR in 2008 and the Value added (% of GDP) of Montenegro in 2011?
Your answer should be very brief. 2.95. What is the difference between the Value added (% of GDP) of Lebanon in 2008 and the Value added (% of GDP) of Montenegro in 2011?
Give a very brief answer. 2.57. What is the difference between the Value added (% of GDP) in Europe(developing only) in 2009 and the Value added (% of GDP) in Lao PDR in 2010?
Your answer should be compact. 9.22. What is the difference between the Value added (% of GDP) in Europe(developing only) in 2009 and the Value added (% of GDP) in Lebanon in 2010?
Offer a terse response. 8.43. What is the difference between the Value added (% of GDP) of Europe(developing only) in 2009 and the Value added (% of GDP) of Montenegro in 2010?
Offer a terse response. 11.23. What is the difference between the Value added (% of GDP) of Lao PDR in 2009 and the Value added (% of GDP) of Lebanon in 2010?
Offer a very short reply. 0.29. What is the difference between the Value added (% of GDP) in Lao PDR in 2009 and the Value added (% of GDP) in Montenegro in 2010?
Ensure brevity in your answer.  3.1. What is the difference between the Value added (% of GDP) of Lebanon in 2009 and the Value added (% of GDP) of Montenegro in 2010?
Your answer should be very brief. 3.14. What is the difference between the Value added (% of GDP) in Europe(developing only) in 2009 and the Value added (% of GDP) in Lao PDR in 2011?
Your response must be concise. 9.16. What is the difference between the Value added (% of GDP) of Europe(developing only) in 2009 and the Value added (% of GDP) of Lebanon in 2011?
Keep it short and to the point. 8.47. What is the difference between the Value added (% of GDP) of Europe(developing only) in 2009 and the Value added (% of GDP) of Montenegro in 2011?
Your response must be concise. 10.75. What is the difference between the Value added (% of GDP) in Lao PDR in 2009 and the Value added (% of GDP) in Lebanon in 2011?
Make the answer very short. 0.33. What is the difference between the Value added (% of GDP) of Lao PDR in 2009 and the Value added (% of GDP) of Montenegro in 2011?
Offer a terse response. 2.62. What is the difference between the Value added (% of GDP) in Lebanon in 2009 and the Value added (% of GDP) in Montenegro in 2011?
Provide a short and direct response. 2.66. What is the difference between the Value added (% of GDP) in Europe(developing only) in 2010 and the Value added (% of GDP) in Lao PDR in 2011?
Ensure brevity in your answer.  9.89. What is the difference between the Value added (% of GDP) of Europe(developing only) in 2010 and the Value added (% of GDP) of Lebanon in 2011?
Provide a short and direct response. 9.19. What is the difference between the Value added (% of GDP) in Europe(developing only) in 2010 and the Value added (% of GDP) in Montenegro in 2011?
Your response must be concise. 11.48. What is the difference between the Value added (% of GDP) in Lao PDR in 2010 and the Value added (% of GDP) in Lebanon in 2011?
Your answer should be very brief. -0.75. What is the difference between the Value added (% of GDP) in Lao PDR in 2010 and the Value added (% of GDP) in Montenegro in 2011?
Your response must be concise. 1.54. What is the difference between the Value added (% of GDP) in Lebanon in 2010 and the Value added (% of GDP) in Montenegro in 2011?
Offer a very short reply. 2.33. What is the average Value added (% of GDP) of Europe(developing only) per year?
Provide a short and direct response. 18.32. What is the average Value added (% of GDP) of Lao PDR per year?
Offer a very short reply. 8.54. What is the average Value added (% of GDP) in Lebanon per year?
Your answer should be very brief. 8.08. What is the average Value added (% of GDP) in Montenegro per year?
Provide a succinct answer. 7.53. In the year 2004, what is the difference between the Value added (% of GDP) in Europe(developing only) and Value added (% of GDP) in Lao PDR?
Provide a short and direct response. 10.94. In the year 2004, what is the difference between the Value added (% of GDP) of Europe(developing only) and Value added (% of GDP) of Lebanon?
Offer a terse response. 11.9. In the year 2004, what is the difference between the Value added (% of GDP) in Europe(developing only) and Value added (% of GDP) in Montenegro?
Your response must be concise. 9.6. In the year 2004, what is the difference between the Value added (% of GDP) of Lao PDR and Value added (% of GDP) of Lebanon?
Provide a succinct answer. 0.96. In the year 2004, what is the difference between the Value added (% of GDP) of Lao PDR and Value added (% of GDP) of Montenegro?
Make the answer very short. -1.34. In the year 2004, what is the difference between the Value added (% of GDP) of Lebanon and Value added (% of GDP) of Montenegro?
Provide a succinct answer. -2.3. In the year 2005, what is the difference between the Value added (% of GDP) in Europe(developing only) and Value added (% of GDP) in Lao PDR?
Offer a very short reply. 9.33. In the year 2005, what is the difference between the Value added (% of GDP) of Europe(developing only) and Value added (% of GDP) of Lebanon?
Give a very brief answer. 11.19. In the year 2005, what is the difference between the Value added (% of GDP) of Europe(developing only) and Value added (% of GDP) of Montenegro?
Give a very brief answer. 9.49. In the year 2005, what is the difference between the Value added (% of GDP) in Lao PDR and Value added (% of GDP) in Lebanon?
Your response must be concise. 1.86. In the year 2005, what is the difference between the Value added (% of GDP) of Lao PDR and Value added (% of GDP) of Montenegro?
Provide a succinct answer. 0.16. In the year 2005, what is the difference between the Value added (% of GDP) in Lebanon and Value added (% of GDP) in Montenegro?
Your answer should be very brief. -1.7. In the year 2006, what is the difference between the Value added (% of GDP) of Europe(developing only) and Value added (% of GDP) of Lao PDR?
Offer a terse response. 10.81. In the year 2006, what is the difference between the Value added (% of GDP) in Europe(developing only) and Value added (% of GDP) in Lebanon?
Your answer should be very brief. 11.74. In the year 2006, what is the difference between the Value added (% of GDP) of Europe(developing only) and Value added (% of GDP) of Montenegro?
Give a very brief answer. 9.81. In the year 2006, what is the difference between the Value added (% of GDP) in Lao PDR and Value added (% of GDP) in Lebanon?
Your answer should be very brief. 0.93. In the year 2006, what is the difference between the Value added (% of GDP) in Lao PDR and Value added (% of GDP) in Montenegro?
Offer a very short reply. -1. In the year 2006, what is the difference between the Value added (% of GDP) in Lebanon and Value added (% of GDP) in Montenegro?
Make the answer very short. -1.93. In the year 2007, what is the difference between the Value added (% of GDP) of Europe(developing only) and Value added (% of GDP) of Lao PDR?
Provide a succinct answer. 9.95. In the year 2007, what is the difference between the Value added (% of GDP) of Europe(developing only) and Value added (% of GDP) of Lebanon?
Provide a short and direct response. 11.04. In the year 2007, what is the difference between the Value added (% of GDP) of Europe(developing only) and Value added (% of GDP) of Montenegro?
Offer a terse response. 11.78. In the year 2007, what is the difference between the Value added (% of GDP) in Lao PDR and Value added (% of GDP) in Lebanon?
Ensure brevity in your answer.  1.09. In the year 2007, what is the difference between the Value added (% of GDP) in Lao PDR and Value added (% of GDP) in Montenegro?
Your answer should be compact. 1.83. In the year 2007, what is the difference between the Value added (% of GDP) in Lebanon and Value added (% of GDP) in Montenegro?
Keep it short and to the point. 0.74. In the year 2008, what is the difference between the Value added (% of GDP) in Europe(developing only) and Value added (% of GDP) in Lao PDR?
Your answer should be very brief. 8.91. In the year 2008, what is the difference between the Value added (% of GDP) in Europe(developing only) and Value added (% of GDP) in Lebanon?
Your answer should be compact. 9.29. In the year 2008, what is the difference between the Value added (% of GDP) of Europe(developing only) and Value added (% of GDP) of Montenegro?
Provide a short and direct response. 11.08. In the year 2008, what is the difference between the Value added (% of GDP) of Lao PDR and Value added (% of GDP) of Lebanon?
Provide a succinct answer. 0.38. In the year 2008, what is the difference between the Value added (% of GDP) in Lao PDR and Value added (% of GDP) in Montenegro?
Your answer should be very brief. 2.16. In the year 2008, what is the difference between the Value added (% of GDP) of Lebanon and Value added (% of GDP) of Montenegro?
Give a very brief answer. 1.78. In the year 2009, what is the difference between the Value added (% of GDP) in Europe(developing only) and Value added (% of GDP) in Lao PDR?
Offer a terse response. 8.13. In the year 2009, what is the difference between the Value added (% of GDP) in Europe(developing only) and Value added (% of GDP) in Lebanon?
Offer a terse response. 8.09. In the year 2009, what is the difference between the Value added (% of GDP) in Europe(developing only) and Value added (% of GDP) in Montenegro?
Provide a short and direct response. 10.79. In the year 2009, what is the difference between the Value added (% of GDP) in Lao PDR and Value added (% of GDP) in Lebanon?
Offer a terse response. -0.04. In the year 2009, what is the difference between the Value added (% of GDP) in Lao PDR and Value added (% of GDP) in Montenegro?
Provide a succinct answer. 2.66. In the year 2009, what is the difference between the Value added (% of GDP) in Lebanon and Value added (% of GDP) in Montenegro?
Keep it short and to the point. 2.7. In the year 2010, what is the difference between the Value added (% of GDP) in Europe(developing only) and Value added (% of GDP) in Lao PDR?
Provide a short and direct response. 9.94. In the year 2010, what is the difference between the Value added (% of GDP) in Europe(developing only) and Value added (% of GDP) in Lebanon?
Provide a succinct answer. 9.15. In the year 2010, what is the difference between the Value added (% of GDP) in Europe(developing only) and Value added (% of GDP) in Montenegro?
Your answer should be compact. 11.96. In the year 2010, what is the difference between the Value added (% of GDP) of Lao PDR and Value added (% of GDP) of Lebanon?
Your response must be concise. -0.79. In the year 2010, what is the difference between the Value added (% of GDP) of Lao PDR and Value added (% of GDP) of Montenegro?
Your answer should be very brief. 2.02. In the year 2010, what is the difference between the Value added (% of GDP) in Lebanon and Value added (% of GDP) in Montenegro?
Provide a succinct answer. 2.81. In the year 2011, what is the difference between the Value added (% of GDP) of Europe(developing only) and Value added (% of GDP) of Lao PDR?
Your answer should be very brief. 10.26. In the year 2011, what is the difference between the Value added (% of GDP) in Europe(developing only) and Value added (% of GDP) in Lebanon?
Your answer should be very brief. 9.56. In the year 2011, what is the difference between the Value added (% of GDP) of Europe(developing only) and Value added (% of GDP) of Montenegro?
Your response must be concise. 11.85. In the year 2011, what is the difference between the Value added (% of GDP) of Lao PDR and Value added (% of GDP) of Lebanon?
Make the answer very short. -0.69. In the year 2011, what is the difference between the Value added (% of GDP) in Lao PDR and Value added (% of GDP) in Montenegro?
Offer a very short reply. 1.59. In the year 2011, what is the difference between the Value added (% of GDP) in Lebanon and Value added (% of GDP) in Montenegro?
Give a very brief answer. 2.28. What is the ratio of the Value added (% of GDP) in Europe(developing only) in 2004 to that in 2005?
Provide a succinct answer. 1.03. What is the ratio of the Value added (% of GDP) of Lao PDR in 2004 to that in 2005?
Your answer should be compact. 0.9. What is the ratio of the Value added (% of GDP) in Lebanon in 2004 to that in 2005?
Your response must be concise. 0.98. What is the ratio of the Value added (% of GDP) in Montenegro in 2004 to that in 2005?
Your answer should be compact. 1.05. What is the ratio of the Value added (% of GDP) of Europe(developing only) in 2004 to that in 2006?
Offer a terse response. 1.03. What is the ratio of the Value added (% of GDP) of Lao PDR in 2004 to that in 2006?
Offer a very short reply. 1.06. What is the ratio of the Value added (% of GDP) of Lebanon in 2004 to that in 2006?
Ensure brevity in your answer.  1.07. What is the ratio of the Value added (% of GDP) in Montenegro in 2004 to that in 2006?
Make the answer very short. 1.09. What is the ratio of the Value added (% of GDP) in Europe(developing only) in 2004 to that in 2007?
Provide a succinct answer. 1.07. What is the ratio of the Value added (% of GDP) of Lao PDR in 2004 to that in 2007?
Your answer should be compact. 1.03. What is the ratio of the Value added (% of GDP) in Lebanon in 2004 to that in 2007?
Your response must be concise. 1.06. What is the ratio of the Value added (% of GDP) in Montenegro in 2004 to that in 2007?
Ensure brevity in your answer.  1.51. What is the ratio of the Value added (% of GDP) of Europe(developing only) in 2004 to that in 2008?
Keep it short and to the point. 1.12. What is the ratio of the Value added (% of GDP) of Lao PDR in 2004 to that in 2008?
Provide a short and direct response. 1. What is the ratio of the Value added (% of GDP) of Lebanon in 2004 to that in 2008?
Your answer should be compact. 0.94. What is the ratio of the Value added (% of GDP) in Montenegro in 2004 to that in 2008?
Make the answer very short. 1.53. What is the ratio of the Value added (% of GDP) in Europe(developing only) in 2004 to that in 2009?
Keep it short and to the point. 1.19. What is the ratio of the Value added (% of GDP) of Lao PDR in 2004 to that in 2009?
Offer a terse response. 1.04. What is the ratio of the Value added (% of GDP) of Lebanon in 2004 to that in 2009?
Your answer should be compact. 0.93. What is the ratio of the Value added (% of GDP) in Montenegro in 2004 to that in 2009?
Your answer should be very brief. 1.74. What is the ratio of the Value added (% of GDP) of Europe(developing only) in 2004 to that in 2010?
Keep it short and to the point. 1.14. What is the ratio of the Value added (% of GDP) in Lao PDR in 2004 to that in 2010?
Your response must be concise. 1.19. What is the ratio of the Value added (% of GDP) of Lebanon in 2004 to that in 2010?
Ensure brevity in your answer.  0.96. What is the ratio of the Value added (% of GDP) of Montenegro in 2004 to that in 2010?
Keep it short and to the point. 1.88. What is the ratio of the Value added (% of GDP) in Europe(developing only) in 2004 to that in 2011?
Provide a short and direct response. 1.12. What is the ratio of the Value added (% of GDP) in Lao PDR in 2004 to that in 2011?
Provide a succinct answer. 1.18. What is the ratio of the Value added (% of GDP) of Lebanon in 2004 to that in 2011?
Provide a short and direct response. 0.97. What is the ratio of the Value added (% of GDP) in Montenegro in 2004 to that in 2011?
Provide a short and direct response. 1.73. What is the ratio of the Value added (% of GDP) in Lao PDR in 2005 to that in 2006?
Keep it short and to the point. 1.18. What is the ratio of the Value added (% of GDP) in Lebanon in 2005 to that in 2006?
Your response must be concise. 1.08. What is the ratio of the Value added (% of GDP) in Montenegro in 2005 to that in 2006?
Give a very brief answer. 1.04. What is the ratio of the Value added (% of GDP) of Europe(developing only) in 2005 to that in 2007?
Ensure brevity in your answer.  1.04. What is the ratio of the Value added (% of GDP) of Lao PDR in 2005 to that in 2007?
Provide a short and direct response. 1.15. What is the ratio of the Value added (% of GDP) of Lebanon in 2005 to that in 2007?
Your answer should be compact. 1.07. What is the ratio of the Value added (% of GDP) in Montenegro in 2005 to that in 2007?
Your answer should be very brief. 1.44. What is the ratio of the Value added (% of GDP) of Europe(developing only) in 2005 to that in 2008?
Provide a short and direct response. 1.08. What is the ratio of the Value added (% of GDP) in Lao PDR in 2005 to that in 2008?
Your response must be concise. 1.12. What is the ratio of the Value added (% of GDP) in Lebanon in 2005 to that in 2008?
Provide a short and direct response. 0.95. What is the ratio of the Value added (% of GDP) in Montenegro in 2005 to that in 2008?
Keep it short and to the point. 1.46. What is the ratio of the Value added (% of GDP) in Europe(developing only) in 2005 to that in 2009?
Keep it short and to the point. 1.15. What is the ratio of the Value added (% of GDP) in Lao PDR in 2005 to that in 2009?
Your answer should be compact. 1.16. What is the ratio of the Value added (% of GDP) in Lebanon in 2005 to that in 2009?
Ensure brevity in your answer.  0.94. What is the ratio of the Value added (% of GDP) of Montenegro in 2005 to that in 2009?
Make the answer very short. 1.66. What is the ratio of the Value added (% of GDP) of Europe(developing only) in 2005 to that in 2010?
Provide a succinct answer. 1.11. What is the ratio of the Value added (% of GDP) in Lao PDR in 2005 to that in 2010?
Your answer should be compact. 1.33. What is the ratio of the Value added (% of GDP) of Lebanon in 2005 to that in 2010?
Provide a succinct answer. 0.98. What is the ratio of the Value added (% of GDP) of Montenegro in 2005 to that in 2010?
Keep it short and to the point. 1.79. What is the ratio of the Value added (% of GDP) in Europe(developing only) in 2005 to that in 2011?
Provide a short and direct response. 1.08. What is the ratio of the Value added (% of GDP) in Lao PDR in 2005 to that in 2011?
Keep it short and to the point. 1.32. What is the ratio of the Value added (% of GDP) in Lebanon in 2005 to that in 2011?
Offer a very short reply. 0.98. What is the ratio of the Value added (% of GDP) in Montenegro in 2005 to that in 2011?
Provide a succinct answer. 1.65. What is the ratio of the Value added (% of GDP) in Europe(developing only) in 2006 to that in 2007?
Provide a short and direct response. 1.03. What is the ratio of the Value added (% of GDP) in Lao PDR in 2006 to that in 2007?
Offer a very short reply. 0.97. What is the ratio of the Value added (% of GDP) of Montenegro in 2006 to that in 2007?
Give a very brief answer. 1.38. What is the ratio of the Value added (% of GDP) in Europe(developing only) in 2006 to that in 2008?
Offer a very short reply. 1.08. What is the ratio of the Value added (% of GDP) of Lao PDR in 2006 to that in 2008?
Make the answer very short. 0.94. What is the ratio of the Value added (% of GDP) of Lebanon in 2006 to that in 2008?
Give a very brief answer. 0.88. What is the ratio of the Value added (% of GDP) of Montenegro in 2006 to that in 2008?
Provide a short and direct response. 1.4. What is the ratio of the Value added (% of GDP) in Europe(developing only) in 2006 to that in 2009?
Make the answer very short. 1.15. What is the ratio of the Value added (% of GDP) in Lao PDR in 2006 to that in 2009?
Offer a terse response. 0.98. What is the ratio of the Value added (% of GDP) of Lebanon in 2006 to that in 2009?
Give a very brief answer. 0.87. What is the ratio of the Value added (% of GDP) in Montenegro in 2006 to that in 2009?
Give a very brief answer. 1.59. What is the ratio of the Value added (% of GDP) of Europe(developing only) in 2006 to that in 2010?
Provide a short and direct response. 1.1. What is the ratio of the Value added (% of GDP) in Lao PDR in 2006 to that in 2010?
Provide a succinct answer. 1.12. What is the ratio of the Value added (% of GDP) in Lebanon in 2006 to that in 2010?
Offer a very short reply. 0.9. What is the ratio of the Value added (% of GDP) of Montenegro in 2006 to that in 2010?
Make the answer very short. 1.72. What is the ratio of the Value added (% of GDP) in Europe(developing only) in 2006 to that in 2011?
Offer a very short reply. 1.08. What is the ratio of the Value added (% of GDP) of Lao PDR in 2006 to that in 2011?
Provide a succinct answer. 1.12. What is the ratio of the Value added (% of GDP) in Lebanon in 2006 to that in 2011?
Your answer should be very brief. 0.91. What is the ratio of the Value added (% of GDP) in Montenegro in 2006 to that in 2011?
Your answer should be very brief. 1.58. What is the ratio of the Value added (% of GDP) of Europe(developing only) in 2007 to that in 2008?
Your answer should be compact. 1.04. What is the ratio of the Value added (% of GDP) in Lao PDR in 2007 to that in 2008?
Your response must be concise. 0.97. What is the ratio of the Value added (% of GDP) of Lebanon in 2007 to that in 2008?
Your answer should be compact. 0.89. What is the ratio of the Value added (% of GDP) in Montenegro in 2007 to that in 2008?
Offer a very short reply. 1.01. What is the ratio of the Value added (% of GDP) in Europe(developing only) in 2007 to that in 2009?
Make the answer very short. 1.11. What is the ratio of the Value added (% of GDP) in Lao PDR in 2007 to that in 2009?
Make the answer very short. 1.01. What is the ratio of the Value added (% of GDP) in Lebanon in 2007 to that in 2009?
Provide a short and direct response. 0.88. What is the ratio of the Value added (% of GDP) in Montenegro in 2007 to that in 2009?
Offer a very short reply. 1.15. What is the ratio of the Value added (% of GDP) in Europe(developing only) in 2007 to that in 2010?
Make the answer very short. 1.07. What is the ratio of the Value added (% of GDP) in Lao PDR in 2007 to that in 2010?
Ensure brevity in your answer.  1.16. What is the ratio of the Value added (% of GDP) of Lebanon in 2007 to that in 2010?
Offer a terse response. 0.91. What is the ratio of the Value added (% of GDP) in Montenegro in 2007 to that in 2010?
Make the answer very short. 1.25. What is the ratio of the Value added (% of GDP) of Europe(developing only) in 2007 to that in 2011?
Your response must be concise. 1.04. What is the ratio of the Value added (% of GDP) of Lao PDR in 2007 to that in 2011?
Offer a terse response. 1.15. What is the ratio of the Value added (% of GDP) in Lebanon in 2007 to that in 2011?
Keep it short and to the point. 0.92. What is the ratio of the Value added (% of GDP) in Montenegro in 2007 to that in 2011?
Provide a short and direct response. 1.15. What is the ratio of the Value added (% of GDP) of Europe(developing only) in 2008 to that in 2009?
Make the answer very short. 1.07. What is the ratio of the Value added (% of GDP) of Lao PDR in 2008 to that in 2009?
Offer a terse response. 1.04. What is the ratio of the Value added (% of GDP) in Montenegro in 2008 to that in 2009?
Provide a short and direct response. 1.14. What is the ratio of the Value added (% of GDP) in Europe(developing only) in 2008 to that in 2010?
Give a very brief answer. 1.02. What is the ratio of the Value added (% of GDP) of Lao PDR in 2008 to that in 2010?
Offer a very short reply. 1.19. What is the ratio of the Value added (% of GDP) of Lebanon in 2008 to that in 2010?
Offer a very short reply. 1.03. What is the ratio of the Value added (% of GDP) of Montenegro in 2008 to that in 2010?
Offer a terse response. 1.23. What is the ratio of the Value added (% of GDP) of Europe(developing only) in 2008 to that in 2011?
Your answer should be compact. 1. What is the ratio of the Value added (% of GDP) in Lao PDR in 2008 to that in 2011?
Provide a succinct answer. 1.18. What is the ratio of the Value added (% of GDP) in Lebanon in 2008 to that in 2011?
Make the answer very short. 1.04. What is the ratio of the Value added (% of GDP) of Montenegro in 2008 to that in 2011?
Offer a very short reply. 1.13. What is the ratio of the Value added (% of GDP) in Europe(developing only) in 2009 to that in 2010?
Keep it short and to the point. 0.96. What is the ratio of the Value added (% of GDP) in Lao PDR in 2009 to that in 2010?
Ensure brevity in your answer.  1.14. What is the ratio of the Value added (% of GDP) in Lebanon in 2009 to that in 2010?
Provide a short and direct response. 1.04. What is the ratio of the Value added (% of GDP) of Montenegro in 2009 to that in 2010?
Your response must be concise. 1.08. What is the ratio of the Value added (% of GDP) in Europe(developing only) in 2009 to that in 2011?
Your answer should be compact. 0.94. What is the ratio of the Value added (% of GDP) in Lao PDR in 2009 to that in 2011?
Your answer should be compact. 1.14. What is the ratio of the Value added (% of GDP) in Lebanon in 2009 to that in 2011?
Provide a succinct answer. 1.05. What is the ratio of the Value added (% of GDP) in Montenegro in 2009 to that in 2011?
Provide a short and direct response. 0.99. What is the ratio of the Value added (% of GDP) in Europe(developing only) in 2010 to that in 2011?
Your response must be concise. 0.98. What is the ratio of the Value added (% of GDP) of Lao PDR in 2010 to that in 2011?
Your answer should be compact. 0.99. What is the ratio of the Value added (% of GDP) of Lebanon in 2010 to that in 2011?
Make the answer very short. 1.01. What is the ratio of the Value added (% of GDP) of Montenegro in 2010 to that in 2011?
Your response must be concise. 0.92. What is the difference between the highest and the second highest Value added (% of GDP) of Europe(developing only)?
Your answer should be very brief. 0.59. What is the difference between the highest and the second highest Value added (% of GDP) in Lao PDR?
Your answer should be very brief. 1.02. What is the difference between the highest and the second highest Value added (% of GDP) of Lebanon?
Provide a succinct answer. 0.09. What is the difference between the highest and the second highest Value added (% of GDP) in Montenegro?
Make the answer very short. 0.47. What is the difference between the highest and the lowest Value added (% of GDP) in Europe(developing only)?
Provide a short and direct response. 3.17. What is the difference between the highest and the lowest Value added (% of GDP) of Lao PDR?
Ensure brevity in your answer.  2.47. What is the difference between the highest and the lowest Value added (% of GDP) of Lebanon?
Provide a short and direct response. 1.13. What is the difference between the highest and the lowest Value added (% of GDP) of Montenegro?
Keep it short and to the point. 4.8. 